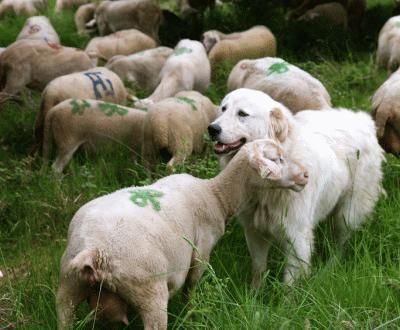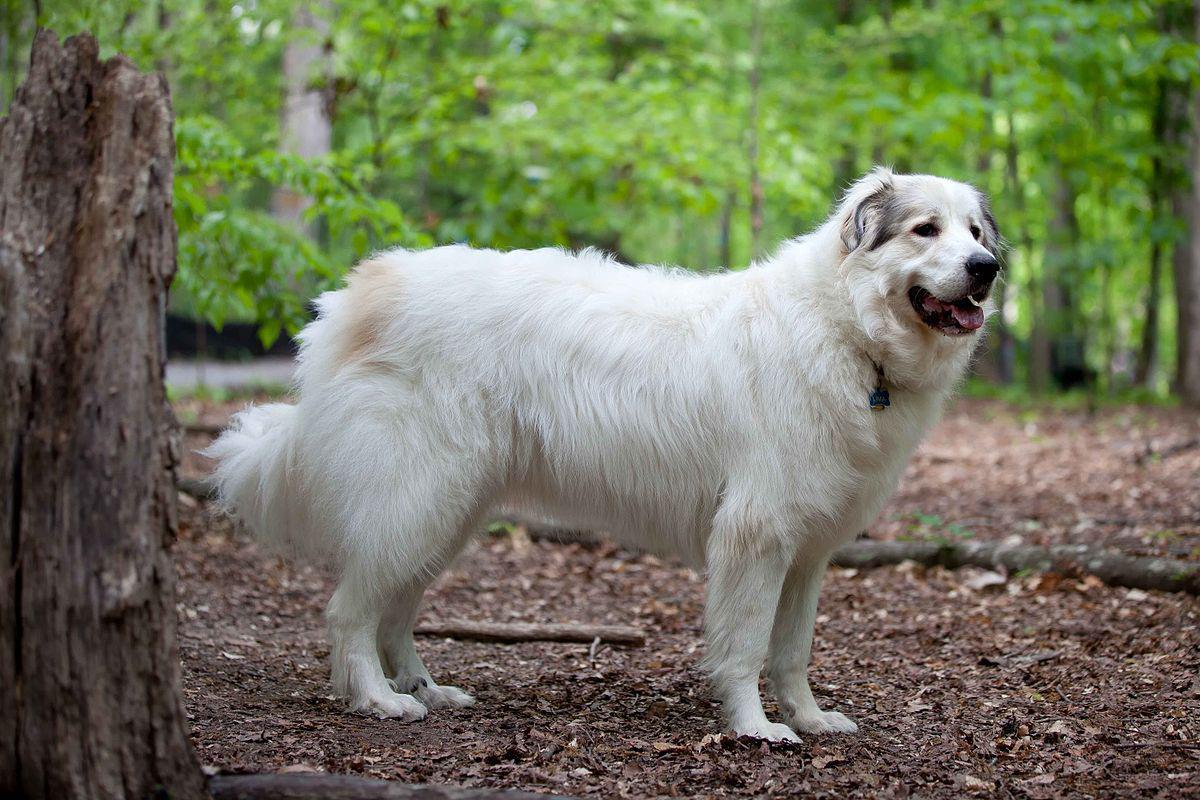The first image is the image on the left, the second image is the image on the right. For the images shown, is this caption "Both images have a fluffy dog with one or more sheep." true? Answer yes or no. No. The first image is the image on the left, the second image is the image on the right. Considering the images on both sides, is "A dog is right next to a sheep in at least one of the images." valid? Answer yes or no. Yes. 